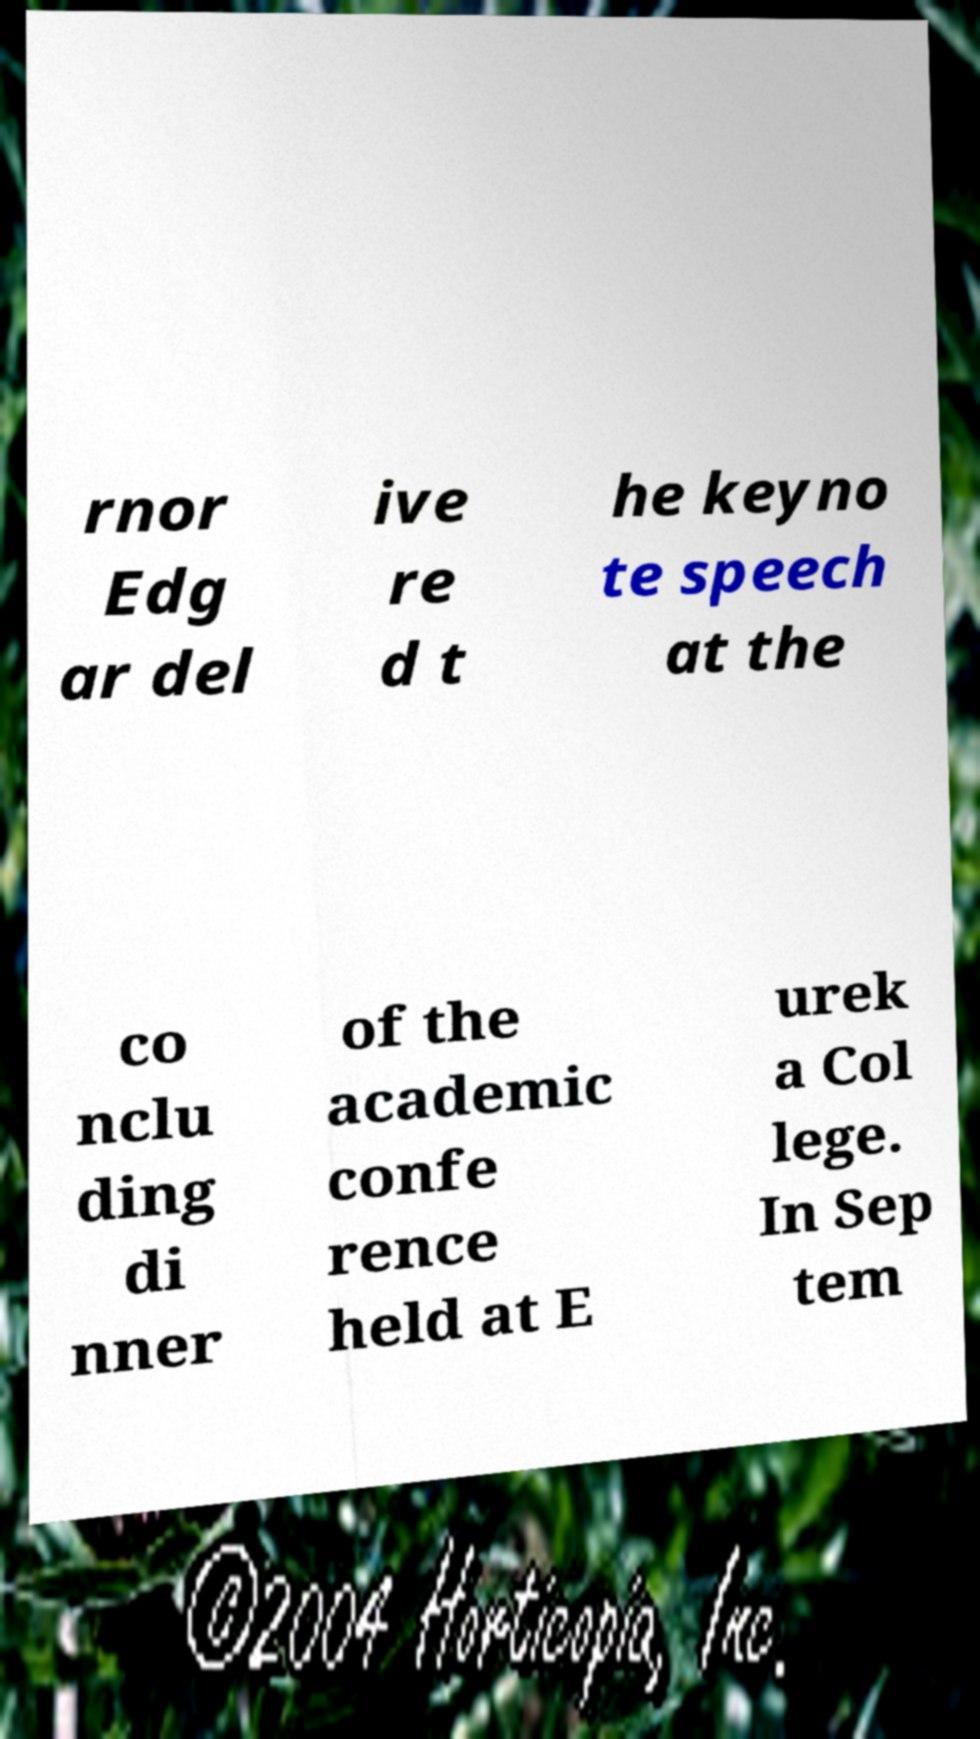Can you read and provide the text displayed in the image?This photo seems to have some interesting text. Can you extract and type it out for me? rnor Edg ar del ive re d t he keyno te speech at the co nclu ding di nner of the academic confe rence held at E urek a Col lege. In Sep tem 